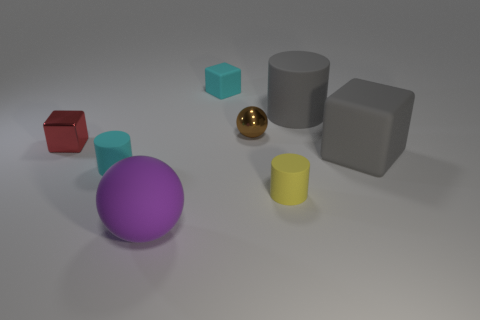How many other large blocks are the same material as the big gray block?
Ensure brevity in your answer.  0. How many big things are either brown shiny things or red things?
Provide a short and direct response. 0. What shape is the matte thing that is both in front of the cyan cylinder and on the right side of the large sphere?
Make the answer very short. Cylinder. Are the large cylinder and the yellow cylinder made of the same material?
Your answer should be compact. Yes. There is a metallic sphere that is the same size as the metal block; what is its color?
Offer a terse response. Brown. There is a big object that is both in front of the red shiny block and behind the matte ball; what is its color?
Offer a terse response. Gray. What size is the cylinder that is the same color as the big matte cube?
Keep it short and to the point. Large. There is a large object that is the same color as the large matte block; what is its shape?
Your answer should be compact. Cylinder. There is a cyan rubber thing that is on the right side of the cyan thing in front of the cyan matte thing that is behind the tiny metallic block; what is its size?
Offer a very short reply. Small. What is the material of the red cube?
Give a very brief answer. Metal. 